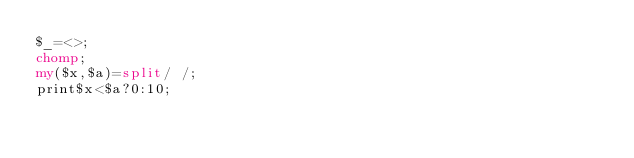Convert code to text. <code><loc_0><loc_0><loc_500><loc_500><_Perl_>$_=<>;
chomp;
my($x,$a)=split/ /;
print$x<$a?0:10;
</code> 